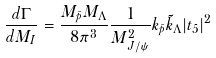Convert formula to latex. <formula><loc_0><loc_0><loc_500><loc_500>\frac { d \Gamma } { d M _ { I } } = \frac { M _ { \bar { p } } M _ { \Lambda } } { 8 \pi ^ { 3 } } \frac { 1 } { M _ { J / \psi } ^ { 2 } } k _ { \bar { p } } \tilde { k } _ { \Lambda } | t _ { 5 } | ^ { 2 }</formula> 